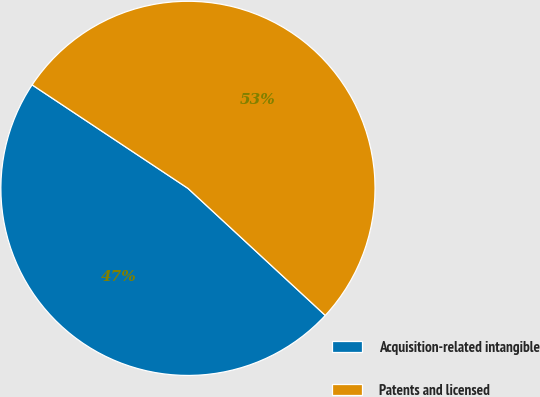Convert chart. <chart><loc_0><loc_0><loc_500><loc_500><pie_chart><fcel>Acquisition-related intangible<fcel>Patents and licensed<nl><fcel>47.45%<fcel>52.55%<nl></chart> 